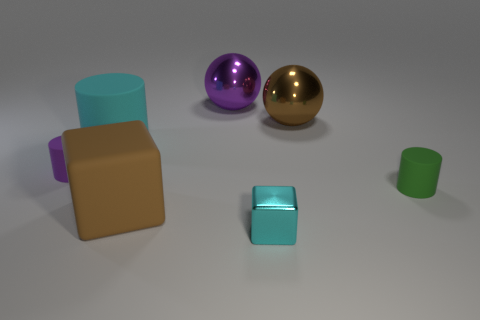How many green cylinders are on the left side of the big cyan rubber cylinder?
Make the answer very short. 0. Is the color of the tiny metallic object the same as the large block?
Ensure brevity in your answer.  No. There is a small cyan object that is the same material as the purple sphere; what shape is it?
Provide a succinct answer. Cube. There is a big rubber object that is behind the big brown block; is it the same shape as the small purple thing?
Offer a terse response. Yes. How many blue objects are either blocks or large balls?
Provide a succinct answer. 0. Are there an equal number of large brown spheres and tiny yellow matte spheres?
Provide a short and direct response. No. Are there an equal number of cyan cubes that are behind the small green rubber object and big purple spheres right of the cyan block?
Your answer should be very brief. Yes. What is the color of the rubber object to the left of the cylinder behind the tiny cylinder on the left side of the big brown matte object?
Give a very brief answer. Purple. Is there any other thing of the same color as the small cube?
Keep it short and to the point. Yes. What shape is the large rubber thing that is the same color as the small metal cube?
Offer a very short reply. Cylinder. 